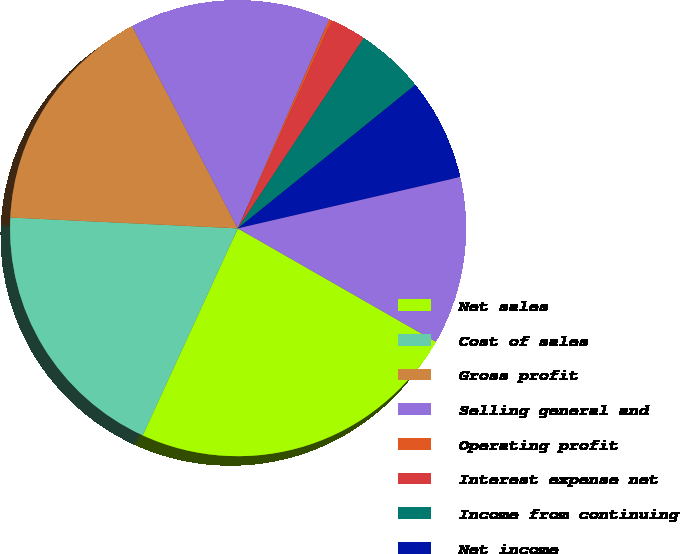<chart> <loc_0><loc_0><loc_500><loc_500><pie_chart><fcel>Net sales<fcel>Cost of sales<fcel>Gross profit<fcel>Selling general and<fcel>Operating profit<fcel>Interest expense net<fcel>Income from continuing<fcel>Net income<fcel>Comprehensive income<nl><fcel>23.58%<fcel>18.9%<fcel>16.57%<fcel>14.23%<fcel>0.2%<fcel>2.54%<fcel>4.88%<fcel>7.21%<fcel>11.89%<nl></chart> 